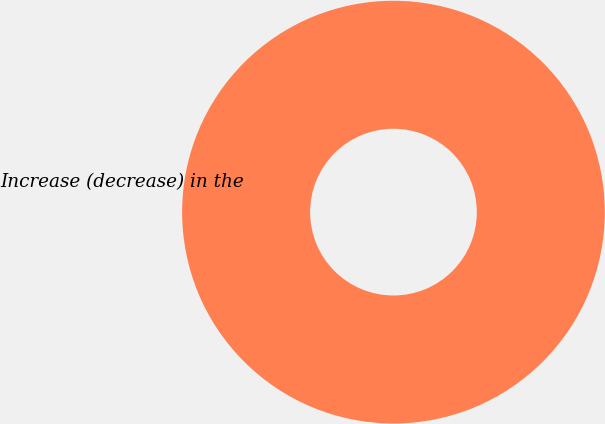Convert chart. <chart><loc_0><loc_0><loc_500><loc_500><pie_chart><fcel>Increase (decrease) in the<nl><fcel>100.0%<nl></chart> 